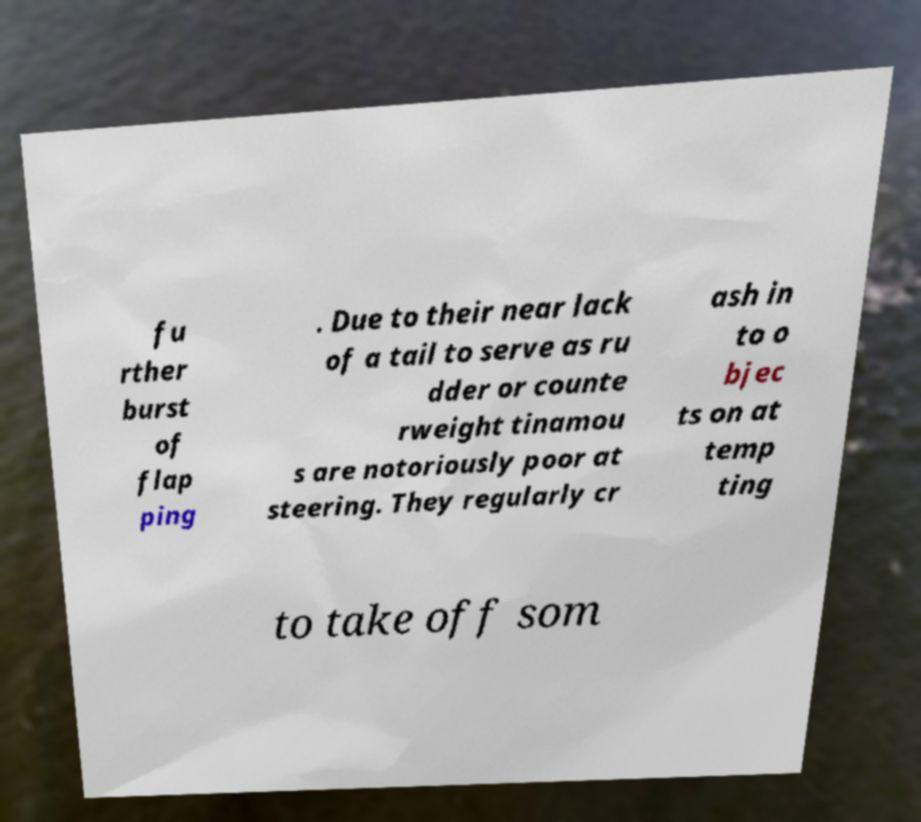I need the written content from this picture converted into text. Can you do that? fu rther burst of flap ping . Due to their near lack of a tail to serve as ru dder or counte rweight tinamou s are notoriously poor at steering. They regularly cr ash in to o bjec ts on at temp ting to take off som 